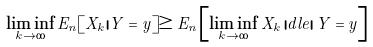Convert formula to latex. <formula><loc_0><loc_0><loc_500><loc_500>\liminf _ { k \to \infty } E _ { n } [ X _ { k } | Y = y ] \geq E _ { n } \left [ \liminf _ { k \to \infty } X _ { k } \, | d l e | \, Y = y \right ]</formula> 